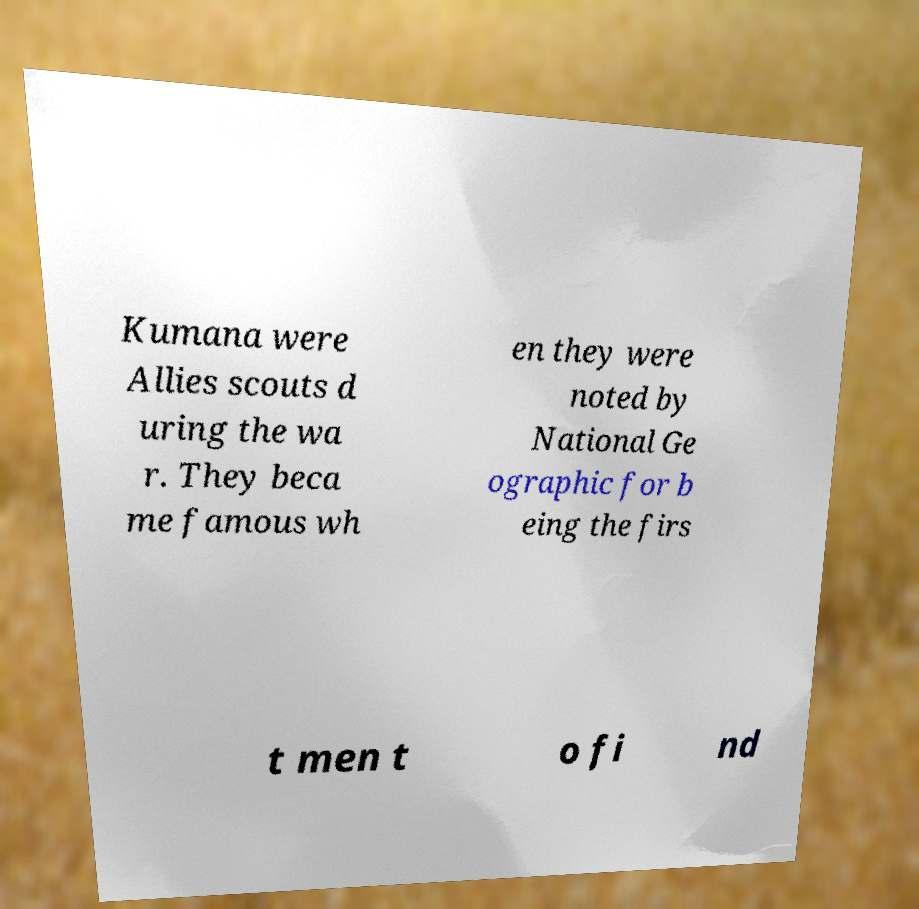I need the written content from this picture converted into text. Can you do that? Kumana were Allies scouts d uring the wa r. They beca me famous wh en they were noted by National Ge ographic for b eing the firs t men t o fi nd 